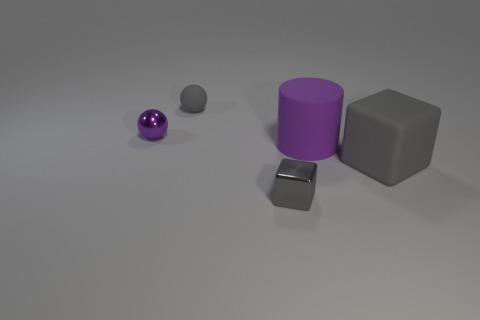Subtract all cylinders. How many objects are left? 4 Add 3 big matte cylinders. How many objects exist? 8 Subtract all gray spheres. How many spheres are left? 1 Subtract 2 balls. How many balls are left? 0 Subtract all matte cylinders. Subtract all big metal cubes. How many objects are left? 4 Add 4 purple rubber cylinders. How many purple rubber cylinders are left? 5 Add 4 small metal blocks. How many small metal blocks exist? 5 Subtract 0 brown cubes. How many objects are left? 5 Subtract all brown cylinders. Subtract all brown blocks. How many cylinders are left? 1 Subtract all green spheres. How many blue cylinders are left? 0 